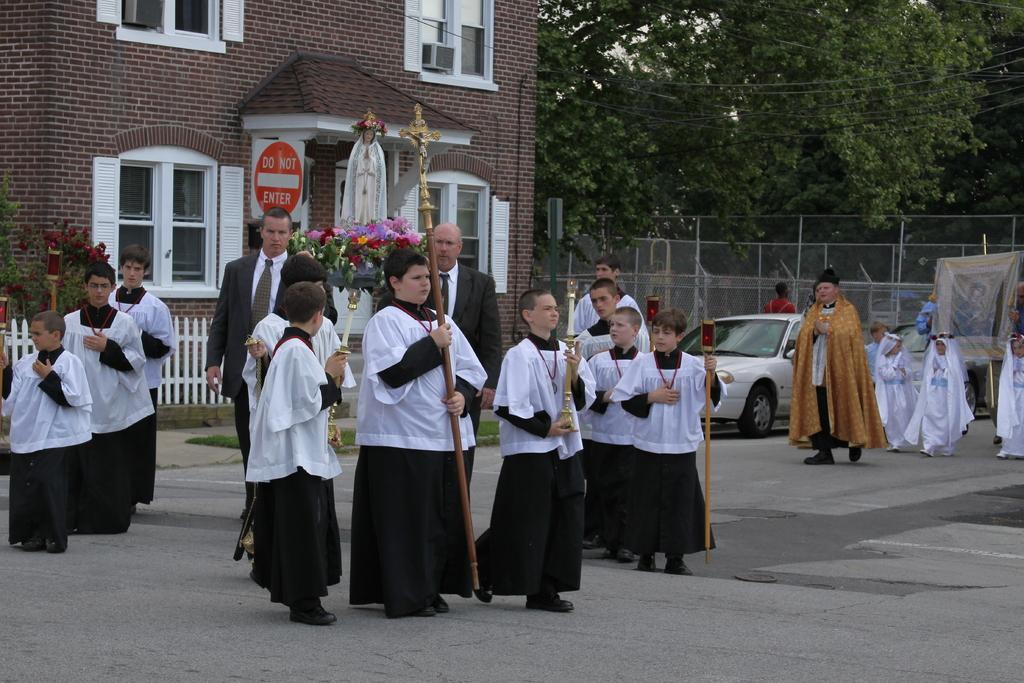Please provide a concise description of this image. In this image we can see this child is holding a cross in his hand and these children are holding candle stands in their hands and walking on the road. Here we can two persons wearing blazers. In the background, we can see the fence, statue, caution board, brick building, cars parked here, wires, poles and the trees. 